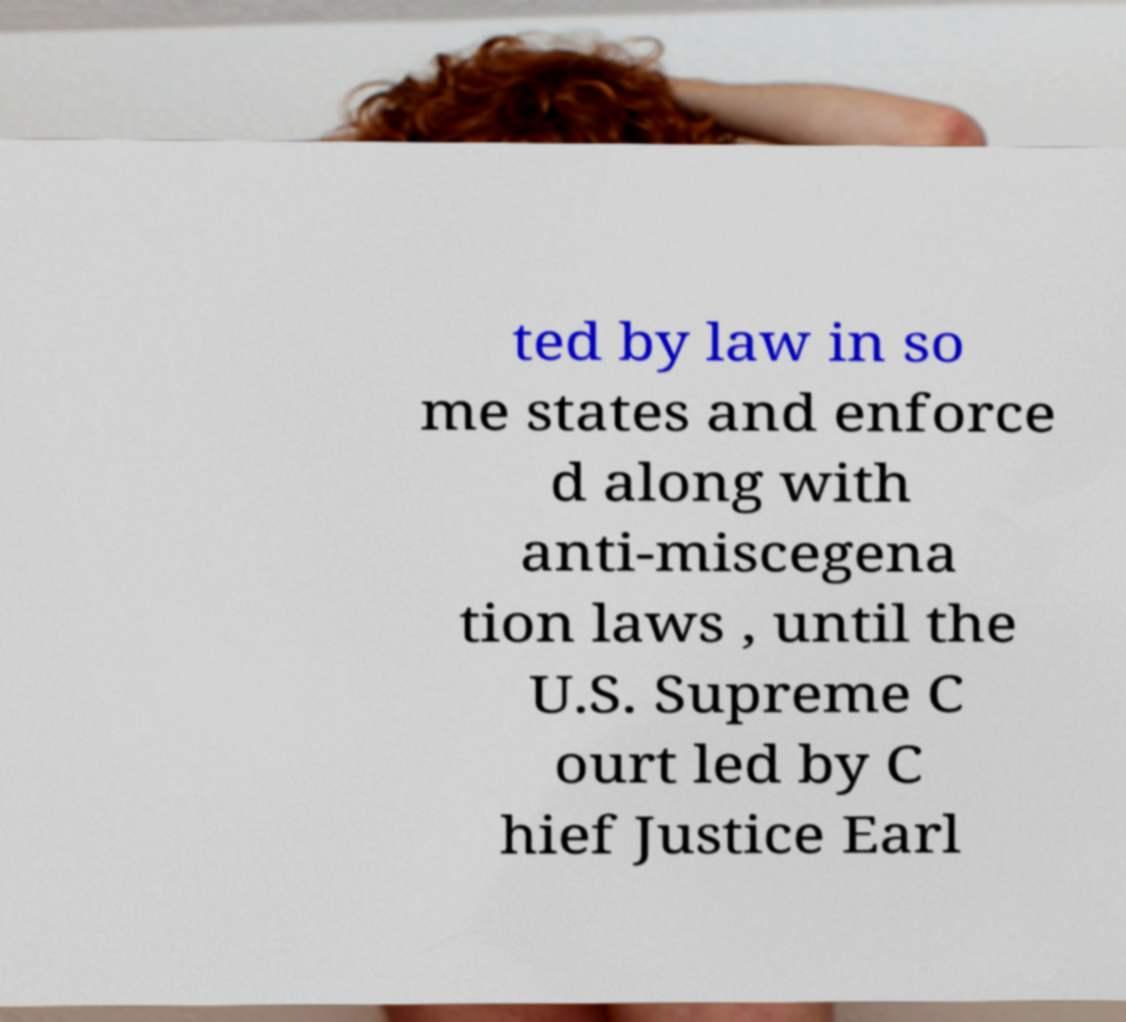For documentation purposes, I need the text within this image transcribed. Could you provide that? ted by law in so me states and enforce d along with anti-miscegena tion laws , until the U.S. Supreme C ourt led by C hief Justice Earl 